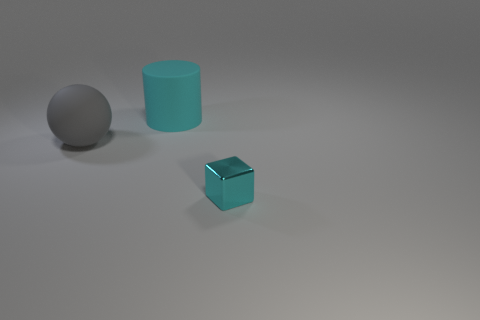Is there a cylinder that has the same material as the sphere?
Give a very brief answer. Yes. The gray thing is what shape?
Provide a succinct answer. Sphere. There is a big thing left of the matte object that is behind the big ball; what shape is it?
Offer a terse response. Sphere. What number of other things are there of the same shape as the tiny cyan metal object?
Your answer should be very brief. 0. There is a matte thing that is in front of the cyan object left of the tiny cube; how big is it?
Your response must be concise. Large. Is there a large gray sphere?
Ensure brevity in your answer.  Yes. There is a cyan object that is to the left of the metallic thing; how many big cyan rubber objects are in front of it?
Provide a short and direct response. 0. There is a big object that is on the left side of the large cyan object; what shape is it?
Your answer should be compact. Sphere. What material is the cyan thing that is on the right side of the cyan object that is to the left of the cyan thing that is to the right of the cyan matte cylinder?
Offer a very short reply. Metal. What number of other objects are the same size as the gray matte sphere?
Give a very brief answer. 1. 